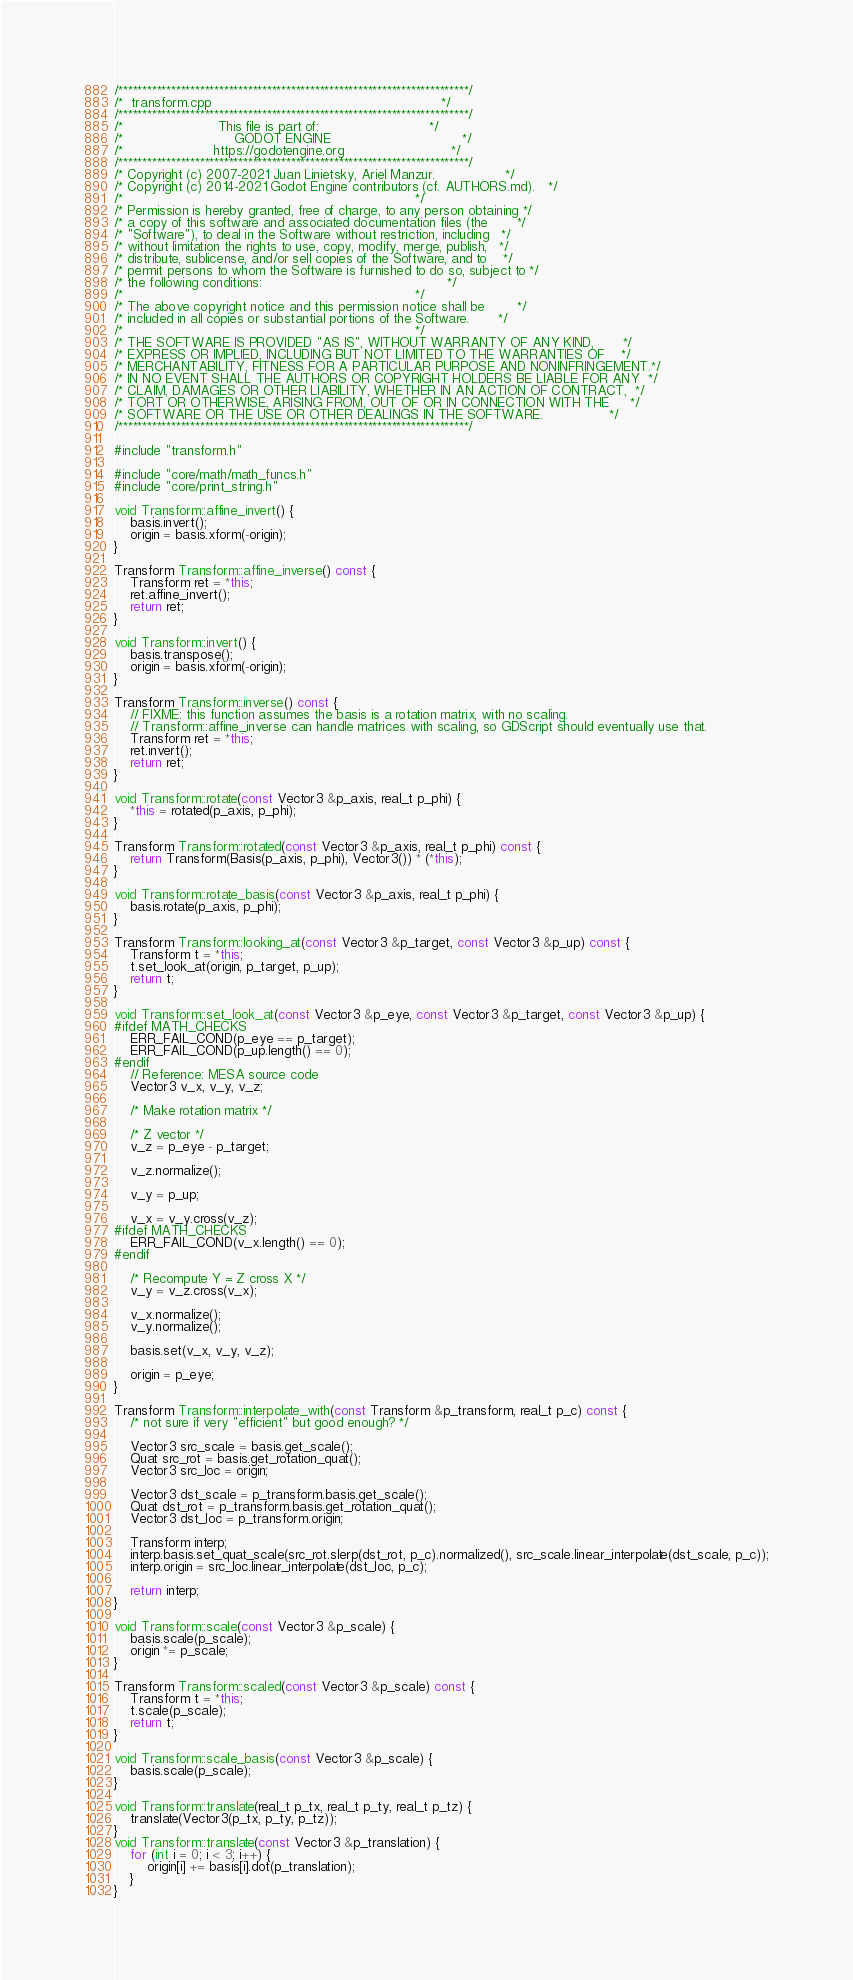Convert code to text. <code><loc_0><loc_0><loc_500><loc_500><_C++_>/*************************************************************************/
/*  transform.cpp                                                        */
/*************************************************************************/
/*                       This file is part of:                           */
/*                           GODOT ENGINE                                */
/*                      https://godotengine.org                          */
/*************************************************************************/
/* Copyright (c) 2007-2021 Juan Linietsky, Ariel Manzur.                 */
/* Copyright (c) 2014-2021 Godot Engine contributors (cf. AUTHORS.md).   */
/*                                                                       */
/* Permission is hereby granted, free of charge, to any person obtaining */
/* a copy of this software and associated documentation files (the       */
/* "Software"), to deal in the Software without restriction, including   */
/* without limitation the rights to use, copy, modify, merge, publish,   */
/* distribute, sublicense, and/or sell copies of the Software, and to    */
/* permit persons to whom the Software is furnished to do so, subject to */
/* the following conditions:                                             */
/*                                                                       */
/* The above copyright notice and this permission notice shall be        */
/* included in all copies or substantial portions of the Software.       */
/*                                                                       */
/* THE SOFTWARE IS PROVIDED "AS IS", WITHOUT WARRANTY OF ANY KIND,       */
/* EXPRESS OR IMPLIED, INCLUDING BUT NOT LIMITED TO THE WARRANTIES OF    */
/* MERCHANTABILITY, FITNESS FOR A PARTICULAR PURPOSE AND NONINFRINGEMENT.*/
/* IN NO EVENT SHALL THE AUTHORS OR COPYRIGHT HOLDERS BE LIABLE FOR ANY  */
/* CLAIM, DAMAGES OR OTHER LIABILITY, WHETHER IN AN ACTION OF CONTRACT,  */
/* TORT OR OTHERWISE, ARISING FROM, OUT OF OR IN CONNECTION WITH THE     */
/* SOFTWARE OR THE USE OR OTHER DEALINGS IN THE SOFTWARE.                */
/*************************************************************************/

#include "transform.h"

#include "core/math/math_funcs.h"
#include "core/print_string.h"

void Transform::affine_invert() {
	basis.invert();
	origin = basis.xform(-origin);
}

Transform Transform::affine_inverse() const {
	Transform ret = *this;
	ret.affine_invert();
	return ret;
}

void Transform::invert() {
	basis.transpose();
	origin = basis.xform(-origin);
}

Transform Transform::inverse() const {
	// FIXME: this function assumes the basis is a rotation matrix, with no scaling.
	// Transform::affine_inverse can handle matrices with scaling, so GDScript should eventually use that.
	Transform ret = *this;
	ret.invert();
	return ret;
}

void Transform::rotate(const Vector3 &p_axis, real_t p_phi) {
	*this = rotated(p_axis, p_phi);
}

Transform Transform::rotated(const Vector3 &p_axis, real_t p_phi) const {
	return Transform(Basis(p_axis, p_phi), Vector3()) * (*this);
}

void Transform::rotate_basis(const Vector3 &p_axis, real_t p_phi) {
	basis.rotate(p_axis, p_phi);
}

Transform Transform::looking_at(const Vector3 &p_target, const Vector3 &p_up) const {
	Transform t = *this;
	t.set_look_at(origin, p_target, p_up);
	return t;
}

void Transform::set_look_at(const Vector3 &p_eye, const Vector3 &p_target, const Vector3 &p_up) {
#ifdef MATH_CHECKS
	ERR_FAIL_COND(p_eye == p_target);
	ERR_FAIL_COND(p_up.length() == 0);
#endif
	// Reference: MESA source code
	Vector3 v_x, v_y, v_z;

	/* Make rotation matrix */

	/* Z vector */
	v_z = p_eye - p_target;

	v_z.normalize();

	v_y = p_up;

	v_x = v_y.cross(v_z);
#ifdef MATH_CHECKS
	ERR_FAIL_COND(v_x.length() == 0);
#endif

	/* Recompute Y = Z cross X */
	v_y = v_z.cross(v_x);

	v_x.normalize();
	v_y.normalize();

	basis.set(v_x, v_y, v_z);

	origin = p_eye;
}

Transform Transform::interpolate_with(const Transform &p_transform, real_t p_c) const {
	/* not sure if very "efficient" but good enough? */

	Vector3 src_scale = basis.get_scale();
	Quat src_rot = basis.get_rotation_quat();
	Vector3 src_loc = origin;

	Vector3 dst_scale = p_transform.basis.get_scale();
	Quat dst_rot = p_transform.basis.get_rotation_quat();
	Vector3 dst_loc = p_transform.origin;

	Transform interp;
	interp.basis.set_quat_scale(src_rot.slerp(dst_rot, p_c).normalized(), src_scale.linear_interpolate(dst_scale, p_c));
	interp.origin = src_loc.linear_interpolate(dst_loc, p_c);

	return interp;
}

void Transform::scale(const Vector3 &p_scale) {
	basis.scale(p_scale);
	origin *= p_scale;
}

Transform Transform::scaled(const Vector3 &p_scale) const {
	Transform t = *this;
	t.scale(p_scale);
	return t;
}

void Transform::scale_basis(const Vector3 &p_scale) {
	basis.scale(p_scale);
}

void Transform::translate(real_t p_tx, real_t p_ty, real_t p_tz) {
	translate(Vector3(p_tx, p_ty, p_tz));
}
void Transform::translate(const Vector3 &p_translation) {
	for (int i = 0; i < 3; i++) {
		origin[i] += basis[i].dot(p_translation);
	}
}
</code> 